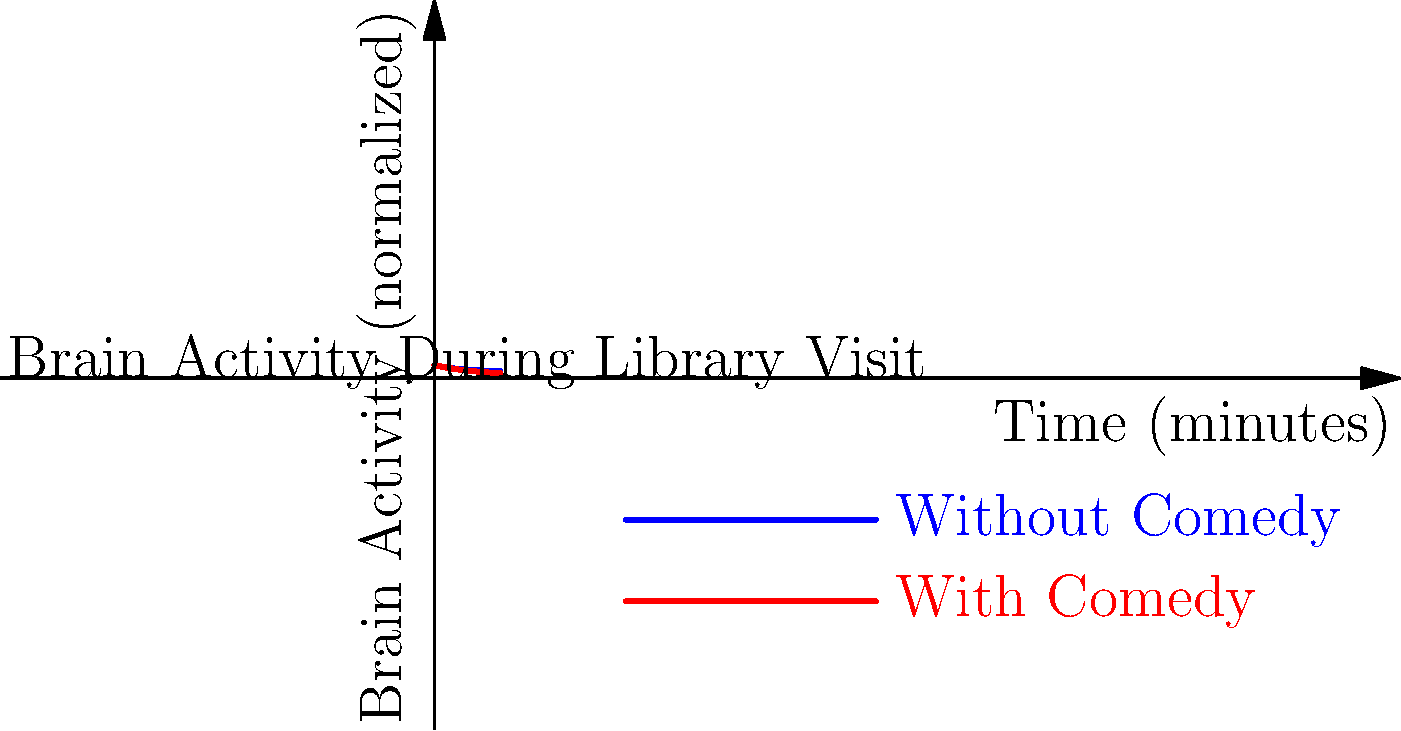Based on the brain activity visualization of library patrons exposed to comedic content versus those who were not, what conclusion can be drawn about the impact of comedy on stress relief in the library setting? To answer this question, we need to analyze the graph and interpret the data:

1. The blue line represents brain activity "Without Comedy," while the red line represents "With Comedy."

2. Both lines show a decrease in brain activity over time, which generally indicates relaxation or stress reduction.

3. The red line (With Comedy) starts at a higher point, suggesting initial stimulation from the comedic content.

4. The red line decreases more rapidly than the blue line, indicating a faster rate of relaxation or stress reduction.

5. By the end of the 5-minute period, the red line is significantly lower than the blue line, suggesting a greater overall reduction in brain activity (and potentially stress) for those exposed to comedy.

6. The area between the two curves represents the difference in brain activity levels, which is consistently larger for the "With Comedy" condition after the initial stimulation.

Given these observations, we can conclude that exposure to comedic content in the library setting leads to a more significant reduction in brain activity over time compared to no comedic exposure. This suggests that comedy has a positive impact on stress relief for library patrons.
Answer: Comedy enhances stress relief, evidenced by faster and greater reduction in brain activity. 